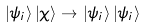<formula> <loc_0><loc_0><loc_500><loc_500>\left | \psi _ { i } \right \rangle \left | \chi \right \rangle \rightarrow \left | \psi _ { i } \right \rangle \left | \psi _ { i } \right \rangle</formula> 